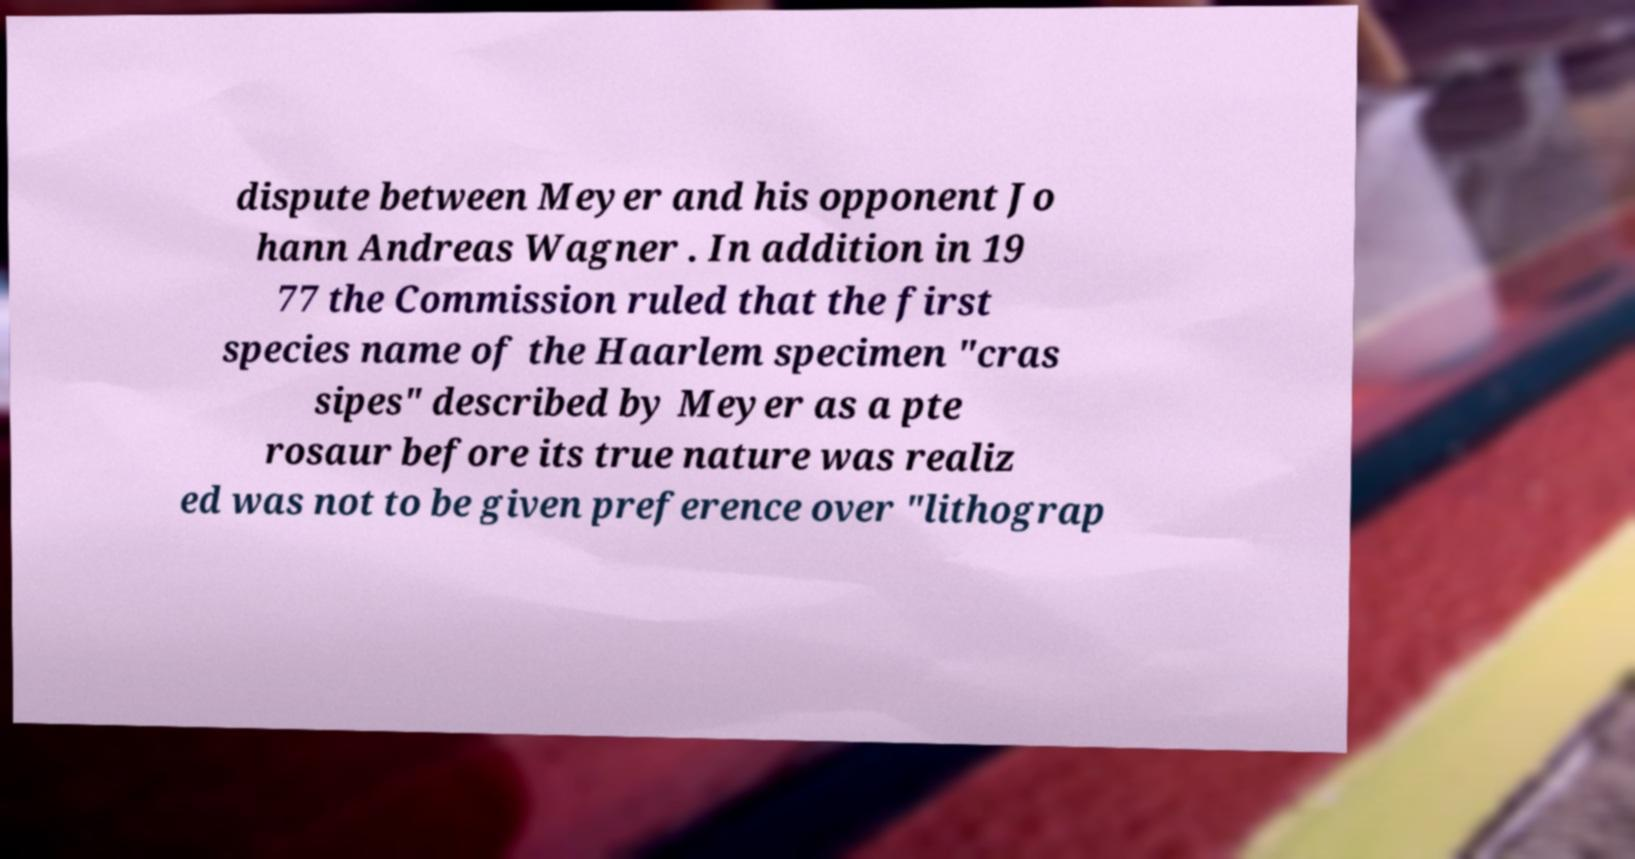Can you accurately transcribe the text from the provided image for me? dispute between Meyer and his opponent Jo hann Andreas Wagner . In addition in 19 77 the Commission ruled that the first species name of the Haarlem specimen "cras sipes" described by Meyer as a pte rosaur before its true nature was realiz ed was not to be given preference over "lithograp 